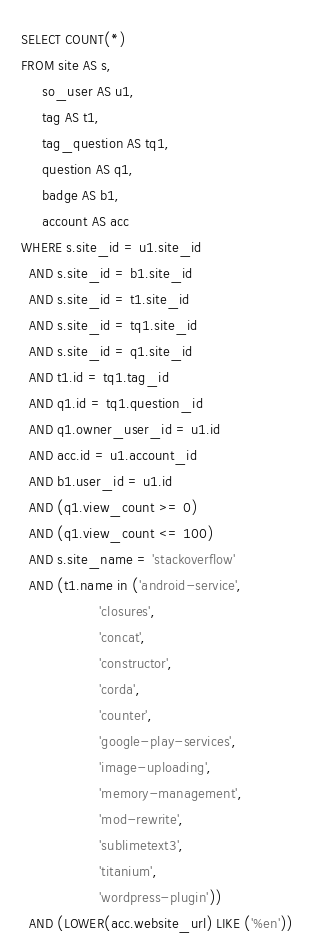Convert code to text. <code><loc_0><loc_0><loc_500><loc_500><_SQL_>SELECT COUNT(*)
FROM site AS s,
     so_user AS u1,
     tag AS t1,
     tag_question AS tq1,
     question AS q1,
     badge AS b1,
     account AS acc
WHERE s.site_id = u1.site_id
  AND s.site_id = b1.site_id
  AND s.site_id = t1.site_id
  AND s.site_id = tq1.site_id
  AND s.site_id = q1.site_id
  AND t1.id = tq1.tag_id
  AND q1.id = tq1.question_id
  AND q1.owner_user_id = u1.id
  AND acc.id = u1.account_id
  AND b1.user_id = u1.id
  AND (q1.view_count >= 0)
  AND (q1.view_count <= 100)
  AND s.site_name = 'stackoverflow'
  AND (t1.name in ('android-service',
                   'closures',
                   'concat',
                   'constructor',
                   'corda',
                   'counter',
                   'google-play-services',
                   'image-uploading',
                   'memory-management',
                   'mod-rewrite',
                   'sublimetext3',
                   'titanium',
                   'wordpress-plugin'))
  AND (LOWER(acc.website_url) LIKE ('%en'))</code> 